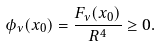Convert formula to latex. <formula><loc_0><loc_0><loc_500><loc_500>\phi _ { \nu } ( x _ { 0 } ) = \frac { F _ { \nu } ( x _ { 0 } ) } { R ^ { 4 } } \geq 0 .</formula> 